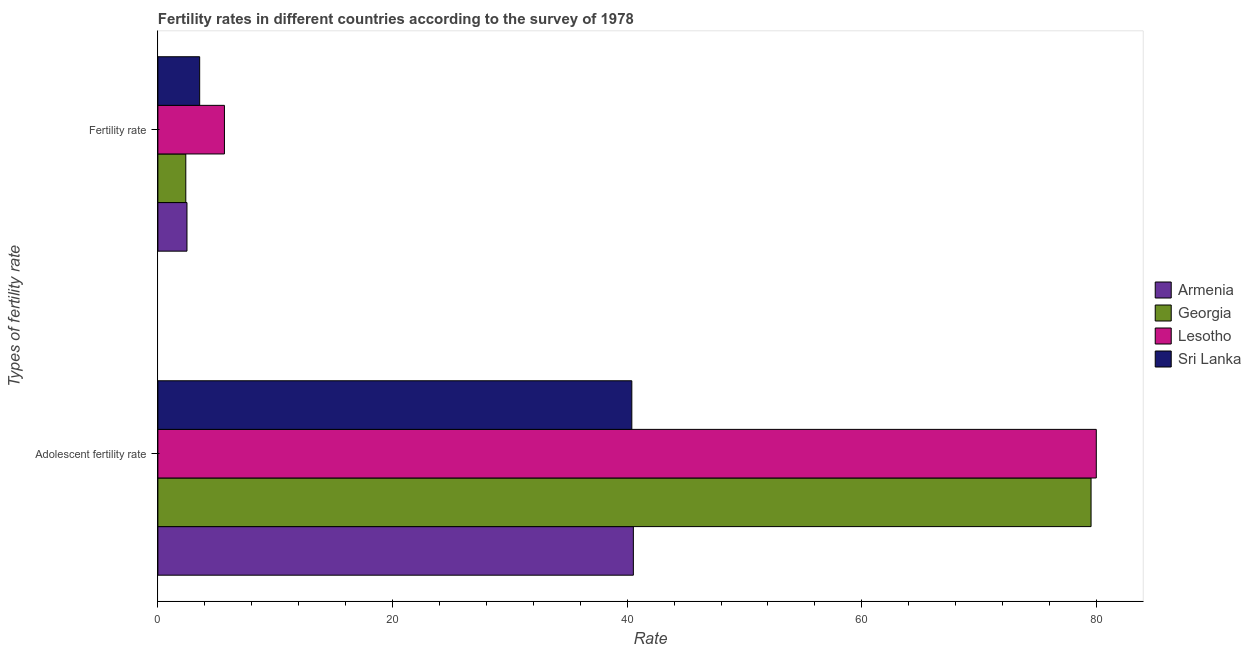Are the number of bars on each tick of the Y-axis equal?
Provide a succinct answer. Yes. What is the label of the 1st group of bars from the top?
Your response must be concise. Fertility rate. What is the fertility rate in Georgia?
Your response must be concise. 2.38. Across all countries, what is the maximum adolescent fertility rate?
Provide a short and direct response. 79.98. Across all countries, what is the minimum adolescent fertility rate?
Keep it short and to the point. 40.4. In which country was the adolescent fertility rate maximum?
Your answer should be compact. Lesotho. In which country was the fertility rate minimum?
Your response must be concise. Georgia. What is the total fertility rate in the graph?
Your response must be concise. 14.09. What is the difference between the fertility rate in Georgia and that in Armenia?
Give a very brief answer. -0.1. What is the difference between the adolescent fertility rate in Lesotho and the fertility rate in Armenia?
Offer a very short reply. 77.5. What is the average adolescent fertility rate per country?
Offer a terse response. 60.11. What is the difference between the fertility rate and adolescent fertility rate in Armenia?
Provide a succinct answer. -38.05. What is the ratio of the fertility rate in Armenia to that in Sri Lanka?
Keep it short and to the point. 0.7. Is the adolescent fertility rate in Lesotho less than that in Georgia?
Ensure brevity in your answer.  No. In how many countries, is the adolescent fertility rate greater than the average adolescent fertility rate taken over all countries?
Provide a short and direct response. 2. What does the 2nd bar from the top in Fertility rate represents?
Provide a short and direct response. Lesotho. What does the 2nd bar from the bottom in Fertility rate represents?
Your response must be concise. Georgia. How many bars are there?
Give a very brief answer. 8. How many countries are there in the graph?
Offer a very short reply. 4. What is the difference between two consecutive major ticks on the X-axis?
Offer a very short reply. 20. Are the values on the major ticks of X-axis written in scientific E-notation?
Make the answer very short. No. Does the graph contain grids?
Your response must be concise. No. Where does the legend appear in the graph?
Offer a very short reply. Center right. What is the title of the graph?
Offer a terse response. Fertility rates in different countries according to the survey of 1978. What is the label or title of the X-axis?
Provide a short and direct response. Rate. What is the label or title of the Y-axis?
Keep it short and to the point. Types of fertility rate. What is the Rate of Armenia in Adolescent fertility rate?
Make the answer very short. 40.53. What is the Rate in Georgia in Adolescent fertility rate?
Ensure brevity in your answer.  79.54. What is the Rate of Lesotho in Adolescent fertility rate?
Make the answer very short. 79.98. What is the Rate in Sri Lanka in Adolescent fertility rate?
Offer a terse response. 40.4. What is the Rate of Armenia in Fertility rate?
Offer a very short reply. 2.48. What is the Rate of Georgia in Fertility rate?
Your answer should be very brief. 2.38. What is the Rate of Lesotho in Fertility rate?
Keep it short and to the point. 5.67. What is the Rate in Sri Lanka in Fertility rate?
Offer a terse response. 3.56. Across all Types of fertility rate, what is the maximum Rate of Armenia?
Ensure brevity in your answer.  40.53. Across all Types of fertility rate, what is the maximum Rate of Georgia?
Give a very brief answer. 79.54. Across all Types of fertility rate, what is the maximum Rate of Lesotho?
Offer a very short reply. 79.98. Across all Types of fertility rate, what is the maximum Rate of Sri Lanka?
Your answer should be very brief. 40.4. Across all Types of fertility rate, what is the minimum Rate in Armenia?
Provide a short and direct response. 2.48. Across all Types of fertility rate, what is the minimum Rate of Georgia?
Ensure brevity in your answer.  2.38. Across all Types of fertility rate, what is the minimum Rate in Lesotho?
Offer a very short reply. 5.67. Across all Types of fertility rate, what is the minimum Rate of Sri Lanka?
Provide a short and direct response. 3.56. What is the total Rate in Armenia in the graph?
Ensure brevity in your answer.  43.01. What is the total Rate in Georgia in the graph?
Give a very brief answer. 81.92. What is the total Rate in Lesotho in the graph?
Provide a short and direct response. 85.66. What is the total Rate in Sri Lanka in the graph?
Offer a very short reply. 43.96. What is the difference between the Rate of Armenia in Adolescent fertility rate and that in Fertility rate?
Your answer should be compact. 38.05. What is the difference between the Rate in Georgia in Adolescent fertility rate and that in Fertility rate?
Keep it short and to the point. 77.16. What is the difference between the Rate of Lesotho in Adolescent fertility rate and that in Fertility rate?
Your answer should be compact. 74.31. What is the difference between the Rate of Sri Lanka in Adolescent fertility rate and that in Fertility rate?
Offer a terse response. 36.83. What is the difference between the Rate of Armenia in Adolescent fertility rate and the Rate of Georgia in Fertility rate?
Your answer should be very brief. 38.15. What is the difference between the Rate of Armenia in Adolescent fertility rate and the Rate of Lesotho in Fertility rate?
Offer a terse response. 34.85. What is the difference between the Rate of Armenia in Adolescent fertility rate and the Rate of Sri Lanka in Fertility rate?
Give a very brief answer. 36.96. What is the difference between the Rate of Georgia in Adolescent fertility rate and the Rate of Lesotho in Fertility rate?
Provide a short and direct response. 73.87. What is the difference between the Rate of Georgia in Adolescent fertility rate and the Rate of Sri Lanka in Fertility rate?
Your answer should be compact. 75.98. What is the difference between the Rate of Lesotho in Adolescent fertility rate and the Rate of Sri Lanka in Fertility rate?
Your answer should be compact. 76.42. What is the average Rate in Armenia per Types of fertility rate?
Ensure brevity in your answer.  21.5. What is the average Rate of Georgia per Types of fertility rate?
Keep it short and to the point. 40.96. What is the average Rate of Lesotho per Types of fertility rate?
Your answer should be compact. 42.83. What is the average Rate of Sri Lanka per Types of fertility rate?
Your answer should be compact. 21.98. What is the difference between the Rate of Armenia and Rate of Georgia in Adolescent fertility rate?
Provide a succinct answer. -39.01. What is the difference between the Rate in Armenia and Rate in Lesotho in Adolescent fertility rate?
Your answer should be very brief. -39.46. What is the difference between the Rate of Armenia and Rate of Sri Lanka in Adolescent fertility rate?
Provide a succinct answer. 0.13. What is the difference between the Rate in Georgia and Rate in Lesotho in Adolescent fertility rate?
Provide a short and direct response. -0.45. What is the difference between the Rate in Georgia and Rate in Sri Lanka in Adolescent fertility rate?
Offer a very short reply. 39.14. What is the difference between the Rate in Lesotho and Rate in Sri Lanka in Adolescent fertility rate?
Offer a terse response. 39.59. What is the difference between the Rate of Armenia and Rate of Georgia in Fertility rate?
Provide a short and direct response. 0.1. What is the difference between the Rate in Armenia and Rate in Lesotho in Fertility rate?
Your answer should be very brief. -3.19. What is the difference between the Rate of Armenia and Rate of Sri Lanka in Fertility rate?
Your response must be concise. -1.08. What is the difference between the Rate of Georgia and Rate of Lesotho in Fertility rate?
Your response must be concise. -3.29. What is the difference between the Rate of Georgia and Rate of Sri Lanka in Fertility rate?
Offer a very short reply. -1.18. What is the difference between the Rate of Lesotho and Rate of Sri Lanka in Fertility rate?
Keep it short and to the point. 2.11. What is the ratio of the Rate of Armenia in Adolescent fertility rate to that in Fertility rate?
Your answer should be very brief. 16.35. What is the ratio of the Rate in Georgia in Adolescent fertility rate to that in Fertility rate?
Make the answer very short. 33.43. What is the ratio of the Rate in Lesotho in Adolescent fertility rate to that in Fertility rate?
Give a very brief answer. 14.1. What is the ratio of the Rate in Sri Lanka in Adolescent fertility rate to that in Fertility rate?
Your response must be concise. 11.34. What is the difference between the highest and the second highest Rate of Armenia?
Your response must be concise. 38.05. What is the difference between the highest and the second highest Rate of Georgia?
Provide a succinct answer. 77.16. What is the difference between the highest and the second highest Rate in Lesotho?
Ensure brevity in your answer.  74.31. What is the difference between the highest and the second highest Rate of Sri Lanka?
Provide a succinct answer. 36.83. What is the difference between the highest and the lowest Rate in Armenia?
Offer a very short reply. 38.05. What is the difference between the highest and the lowest Rate in Georgia?
Ensure brevity in your answer.  77.16. What is the difference between the highest and the lowest Rate of Lesotho?
Provide a short and direct response. 74.31. What is the difference between the highest and the lowest Rate of Sri Lanka?
Your answer should be compact. 36.83. 